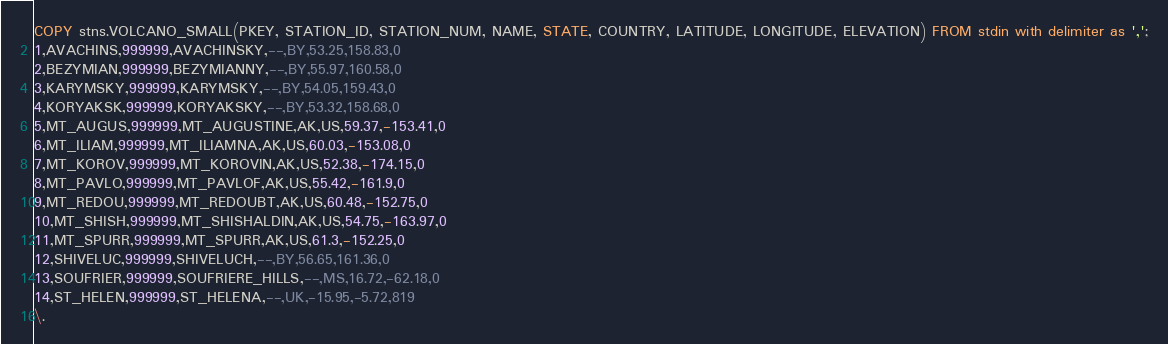<code> <loc_0><loc_0><loc_500><loc_500><_SQL_>COPY stns.VOLCANO_SMALL(PKEY, STATION_ID, STATION_NUM, NAME, STATE, COUNTRY, LATITUDE, LONGITUDE, ELEVATION) FROM stdin with delimiter as ',';
1,AVACHINS,999999,AVACHINSKY,--,BY,53.25,158.83,0
2,BEZYMIAN,999999,BEZYMIANNY,--,BY,55.97,160.58,0
3,KARYMSKY,999999,KARYMSKY,--,BY,54.05,159.43,0
4,KORYAKSK,999999,KORYAKSKY,--,BY,53.32,158.68,0
5,MT_AUGUS,999999,MT_AUGUSTINE,AK,US,59.37,-153.41,0
6,MT_ILIAM,999999,MT_ILIAMNA,AK,US,60.03,-153.08,0
7,MT_KOROV,999999,MT_KOROVIN,AK,US,52.38,-174.15,0
8,MT_PAVLO,999999,MT_PAVLOF,AK,US,55.42,-161.9,0
9,MT_REDOU,999999,MT_REDOUBT,AK,US,60.48,-152.75,0
10,MT_SHISH,999999,MT_SHISHALDIN,AK,US,54.75,-163.97,0
11,MT_SPURR,999999,MT_SPURR,AK,US,61.3,-152.25,0
12,SHIVELUC,999999,SHIVELUCH,--,BY,56.65,161.36,0
13,SOUFRIER,999999,SOUFRIERE_HILLS,--,MS,16.72,-62.18,0
14,ST_HELEN,999999,ST_HELENA,--,UK,-15.95,-5.72,819
\.
</code> 